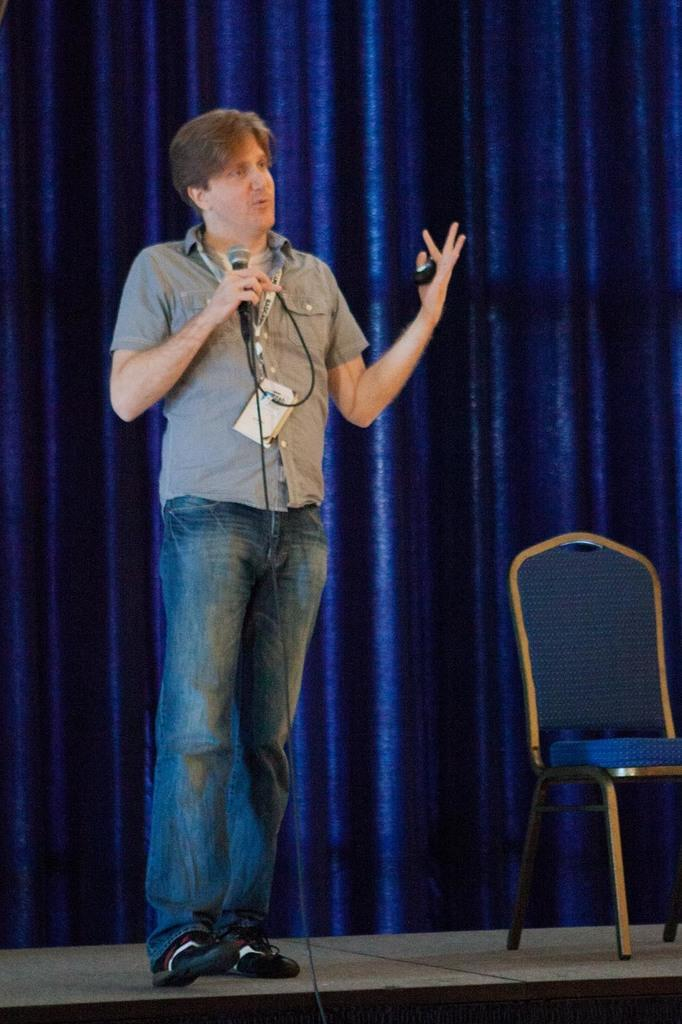What is the man in the image doing? The man is standing in the image and talking into a microphone. What can be seen in the background of the image? There are chairs and a curtain in the background of the image. Is there a tiger sitting on one of the chairs in the background of the image? No, there is no tiger present in the image. 